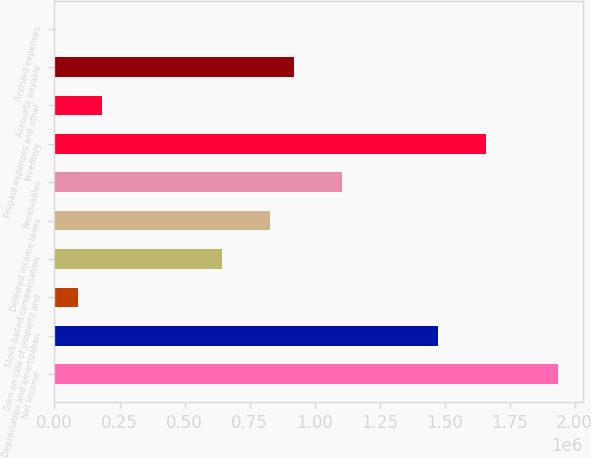Convert chart to OTSL. <chart><loc_0><loc_0><loc_500><loc_500><bar_chart><fcel>Net income<fcel>Depreciation and amortization<fcel>Gain on sale of property and<fcel>Stock-based compensation<fcel>Deferred income taxes<fcel>Receivables<fcel>Inventory<fcel>Prepaid expenses and other<fcel>Accounts payable<fcel>Accrued expenses<nl><fcel>1.93529e+06<fcel>1.47453e+06<fcel>92271.8<fcel>645177<fcel>829478<fcel>1.10593e+06<fcel>1.65884e+06<fcel>184423<fcel>921629<fcel>121<nl></chart> 